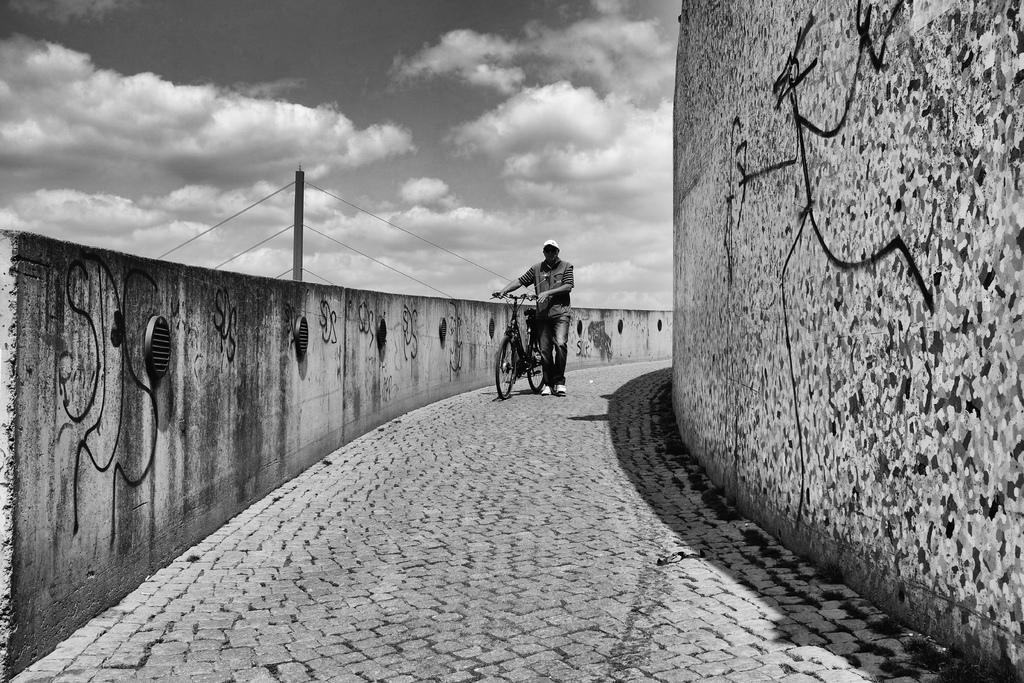Who is present in the image? There is a person in the image. What is the person holding in the image? The person is holding a bicycle. What is the person doing in the image? The person is walking on a path. What type of structures can be seen in the image? There are walls visible in the image. What is the weather like in the image? The sky is clouded in the image. How many dimes can be seen on the person's forehead in the image? There are no dimes visible on the person's forehead in the image. 